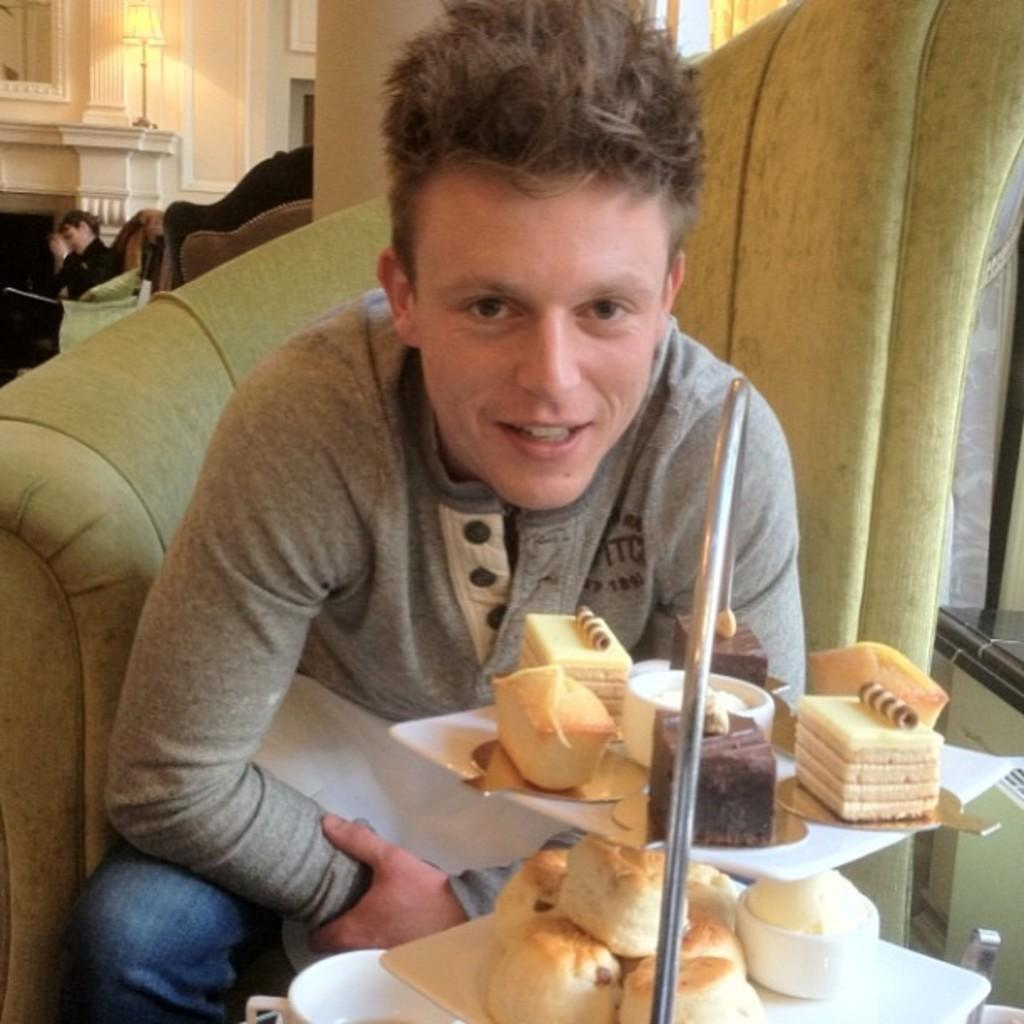Who is present in the image? There is a man in the image. What is in front of the man? There are food items, plates, and other objects in front of the man. Can you describe the background of the image? There is a person, a wall, a lamp, and other objects in the background of the image. How does the man increase the size of the bead in the image? There is no bead present in the image, so it is not possible to answer that question. 